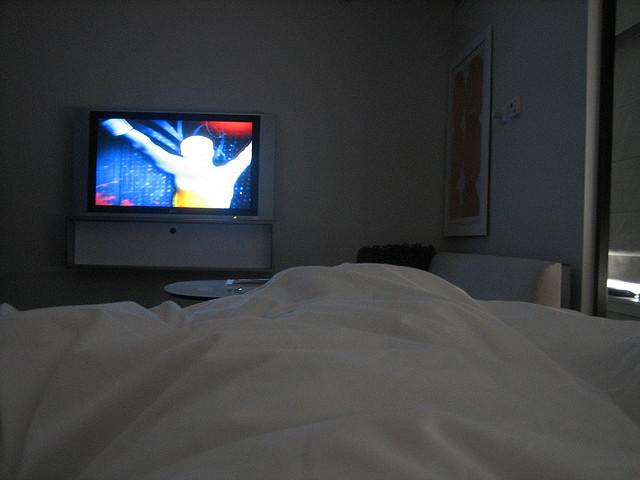Do people normally have a TV in the bedroom?
Be succinct. Yes. Is it day or night?
Keep it brief. Night. What does the green light, on the TV, indicate?
Be succinct. On. Is this a hotel?
Write a very short answer. No. Is this a computer screen?
Answer briefly. No. 